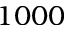Convert formula to latex. <formula><loc_0><loc_0><loc_500><loc_500>1 0 0 0</formula> 